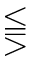<formula> <loc_0><loc_0><loc_500><loc_500>\leq s s e q q g t r</formula> 